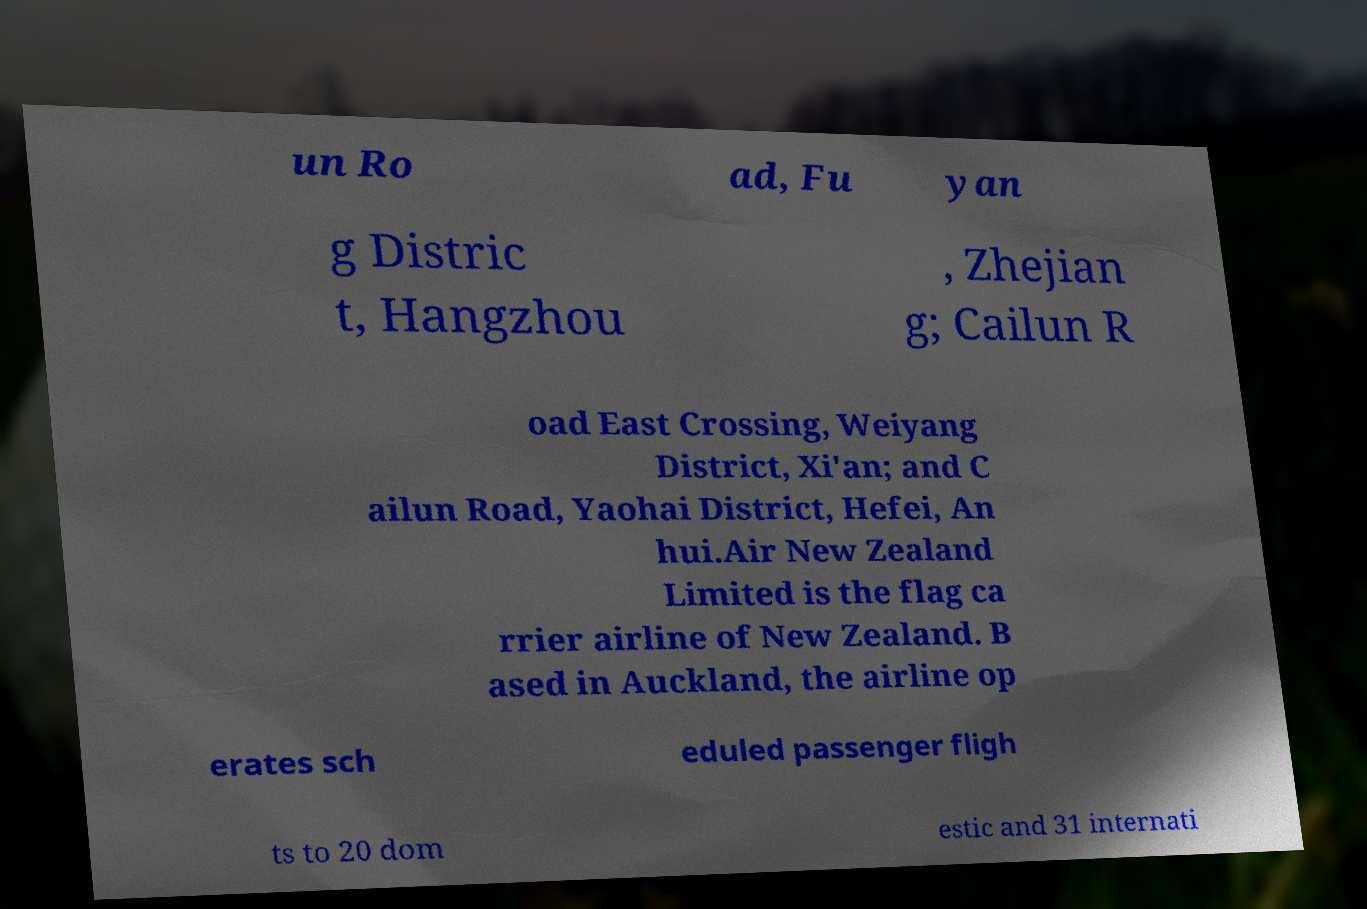I need the written content from this picture converted into text. Can you do that? un Ro ad, Fu yan g Distric t, Hangzhou , Zhejian g; Cailun R oad East Crossing, Weiyang District, Xi'an; and C ailun Road, Yaohai District, Hefei, An hui.Air New Zealand Limited is the flag ca rrier airline of New Zealand. B ased in Auckland, the airline op erates sch eduled passenger fligh ts to 20 dom estic and 31 internati 